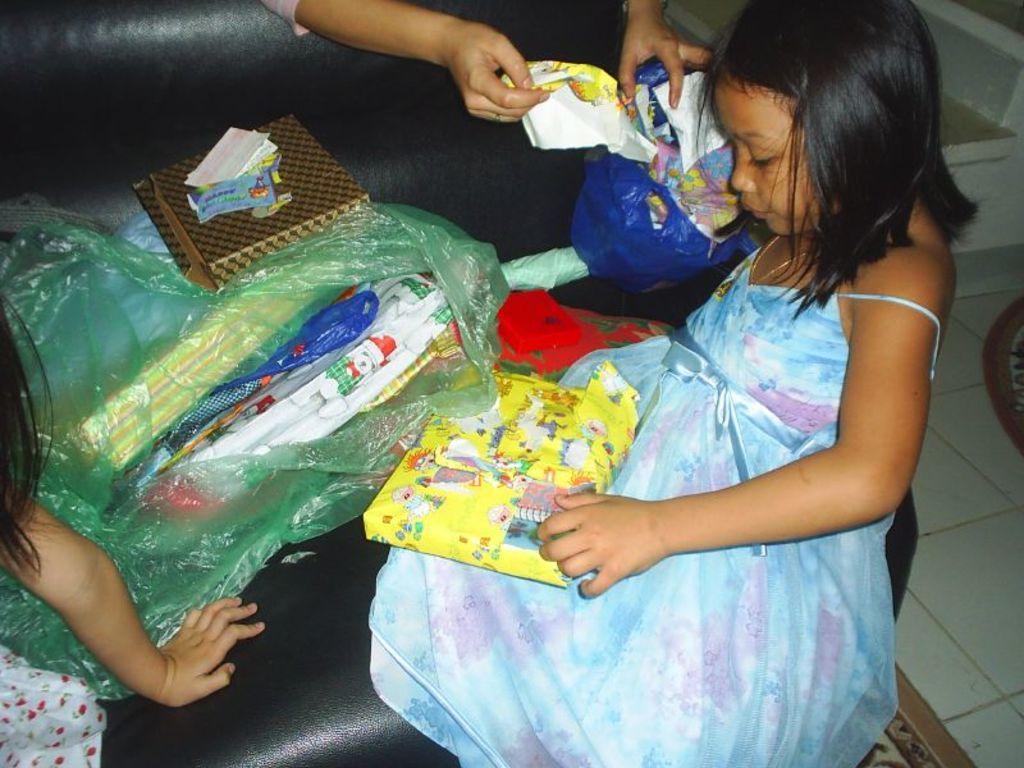Could you give a brief overview of what you see in this image? This picture consists of a girl holding plastic cover, on the left side there is another girl , in the middle there are few plastic covers and boxes kept on couch , at the top I can see person's hand which is holding plastic covers and on the right side white color marble is visible 